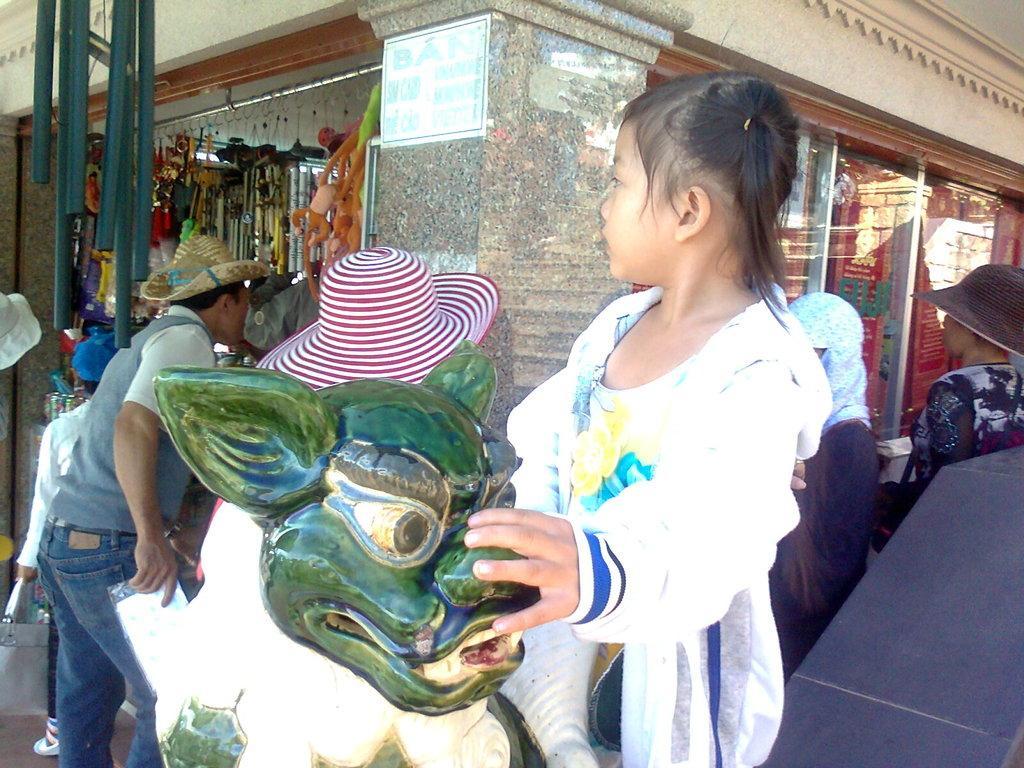Can you describe this image briefly? This image is taken outdoors. In the background there is a building with walls and doors. There is a pillar. There are many things and objects in the store. There is a board with a text on the pillar. In the middle of the image there is a statue of an animal and there are a few people standing on the floor. A kid is holding a statue. On the right side of the image there are two persons and there is an object. 